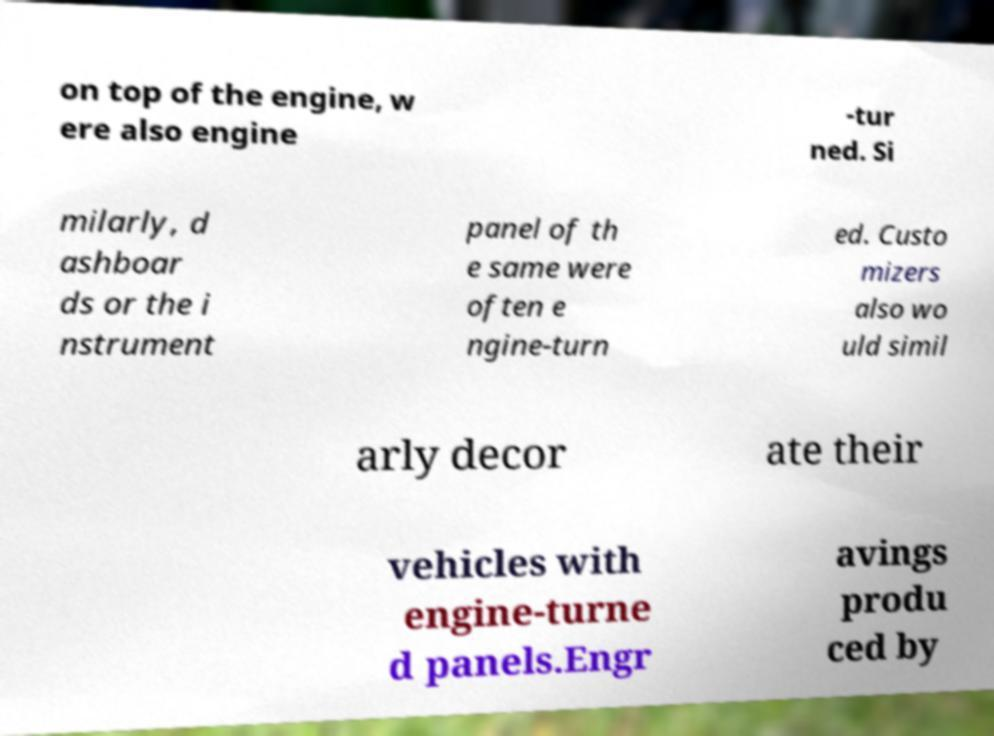Can you accurately transcribe the text from the provided image for me? on top of the engine, w ere also engine -tur ned. Si milarly, d ashboar ds or the i nstrument panel of th e same were often e ngine-turn ed. Custo mizers also wo uld simil arly decor ate their vehicles with engine-turne d panels.Engr avings produ ced by 